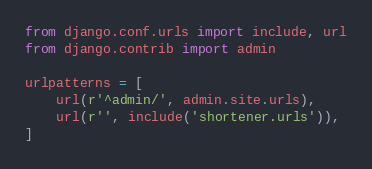<code> <loc_0><loc_0><loc_500><loc_500><_Python_>from django.conf.urls import include, url
from django.contrib import admin

urlpatterns = [
    url(r'^admin/', admin.site.urls),
    url(r'', include('shortener.urls')),
]
</code> 